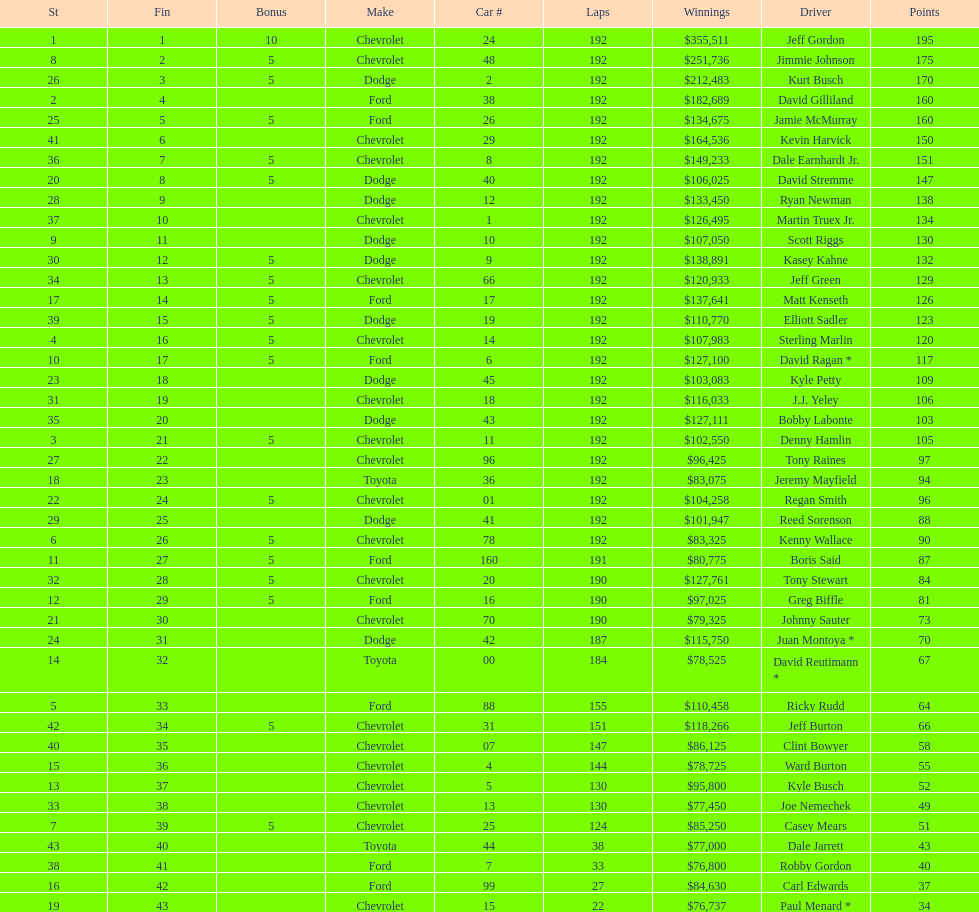What driver earned the least amount of winnings? Paul Menard *. 